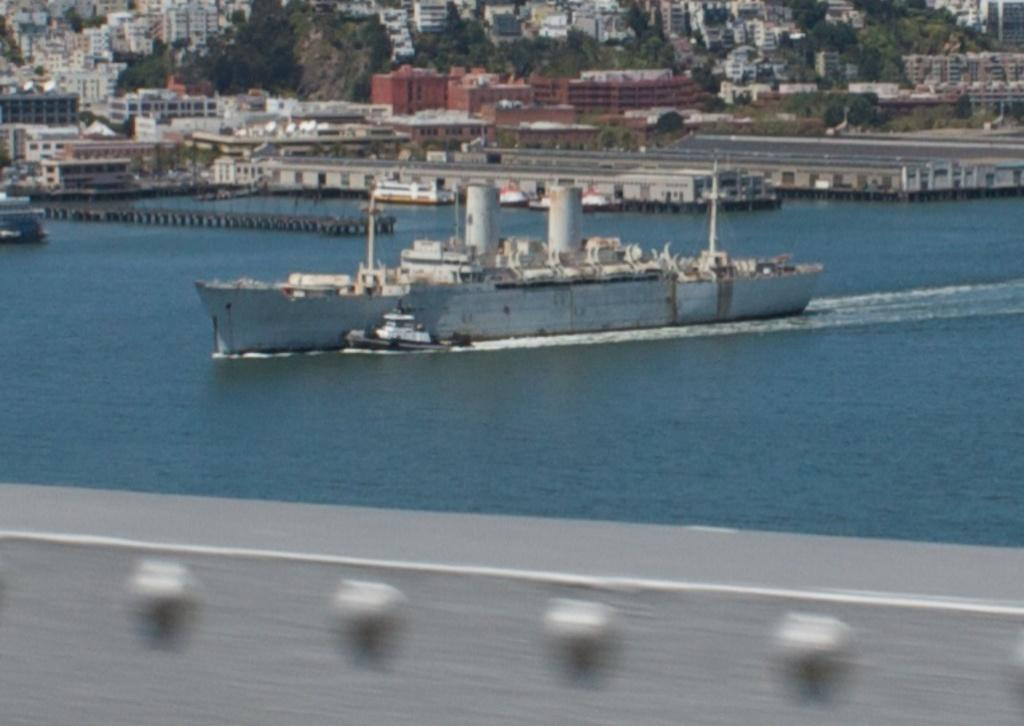What can be seen floating on the water in the image? There are ships on the water in the image. What type of structures are visible in the image? There are buildings in the image. What type of vegetation is present in the image? There are trees in the image. What type of vertical structures can be seen in the image? There are poles in the image. What type of openings are present in the buildings in the image? There are windows in the image. What type of jam is being served on the ships in the image? There is no jam present in the image; it features ships on the water, buildings, trees, poles, and windows. How can the ships be stopped using the brake in the image? There is no brake present in the image; ships do not have brakes like vehicles. 